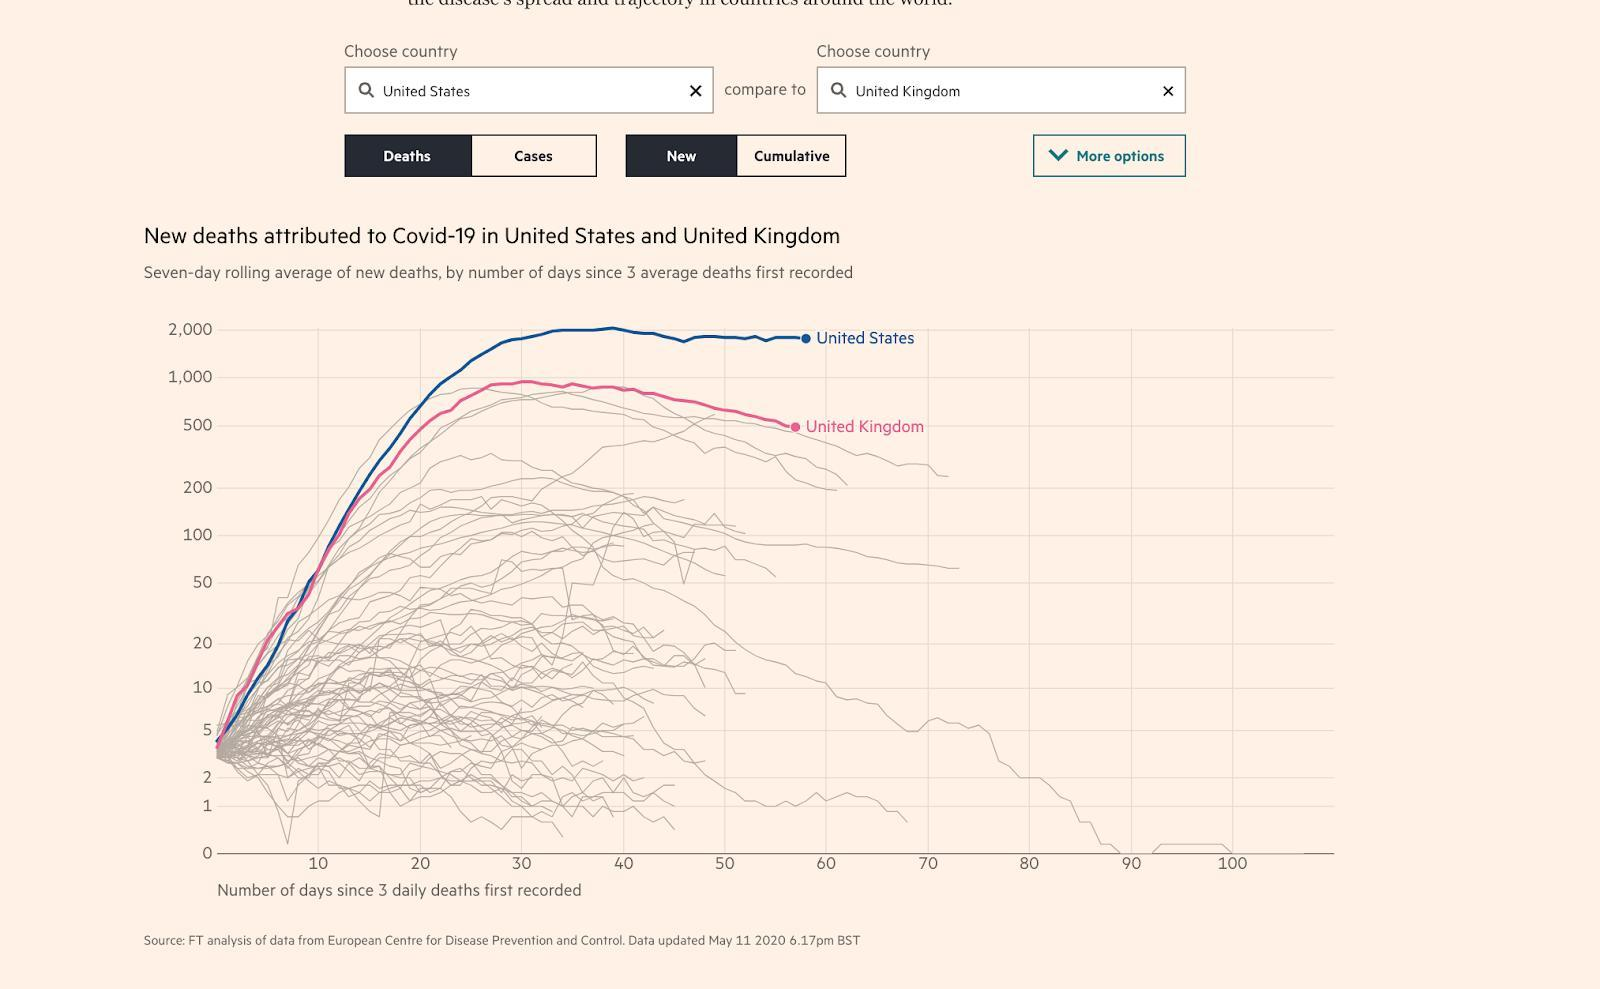THe red line represents which country
Answer the question with a short phrase. united kingdom the blue line represents which country United states 